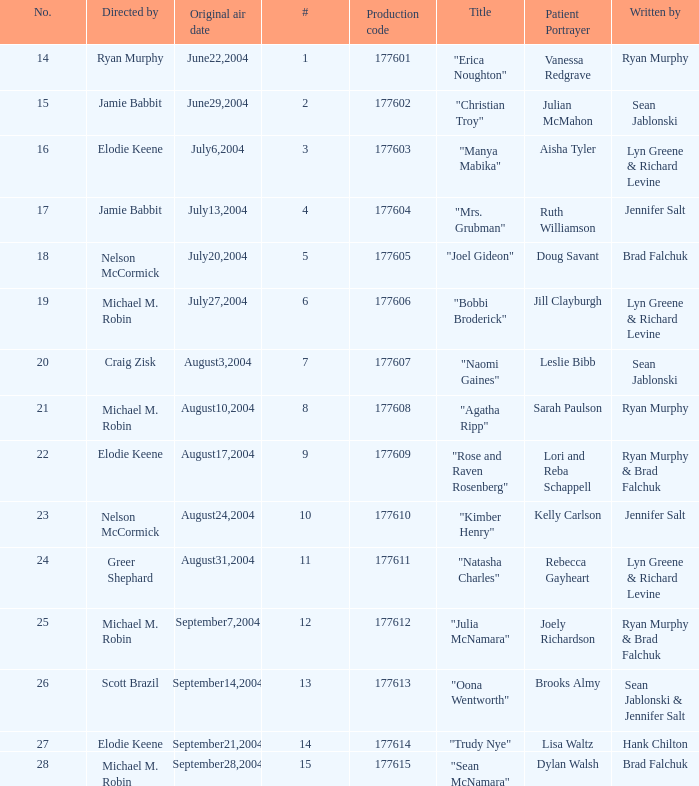Who directed the episode with production code 177605? Nelson McCormick. 